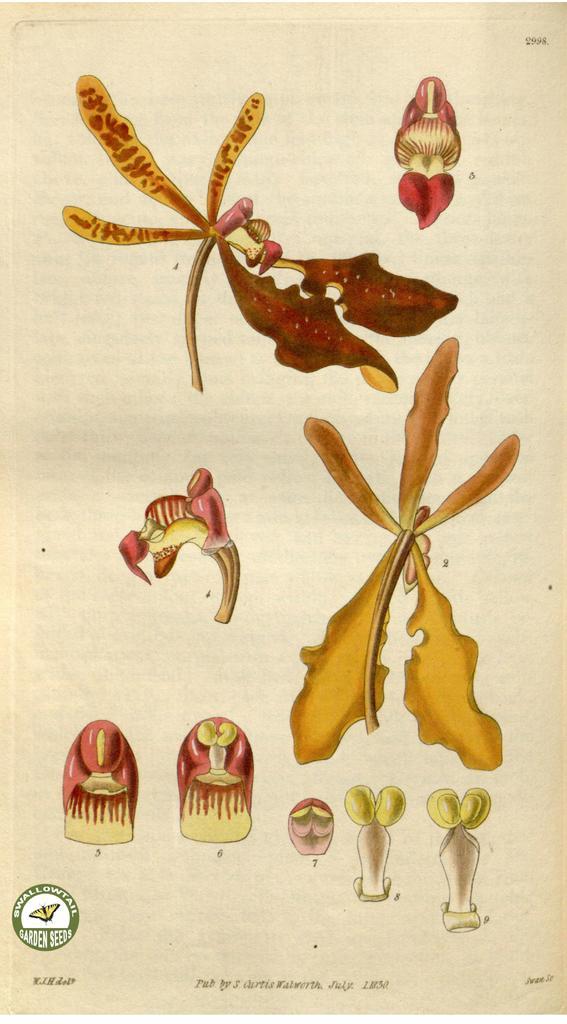Describe this image in one or two sentences. In this image there is a paper with some image and some text at the bottom. 